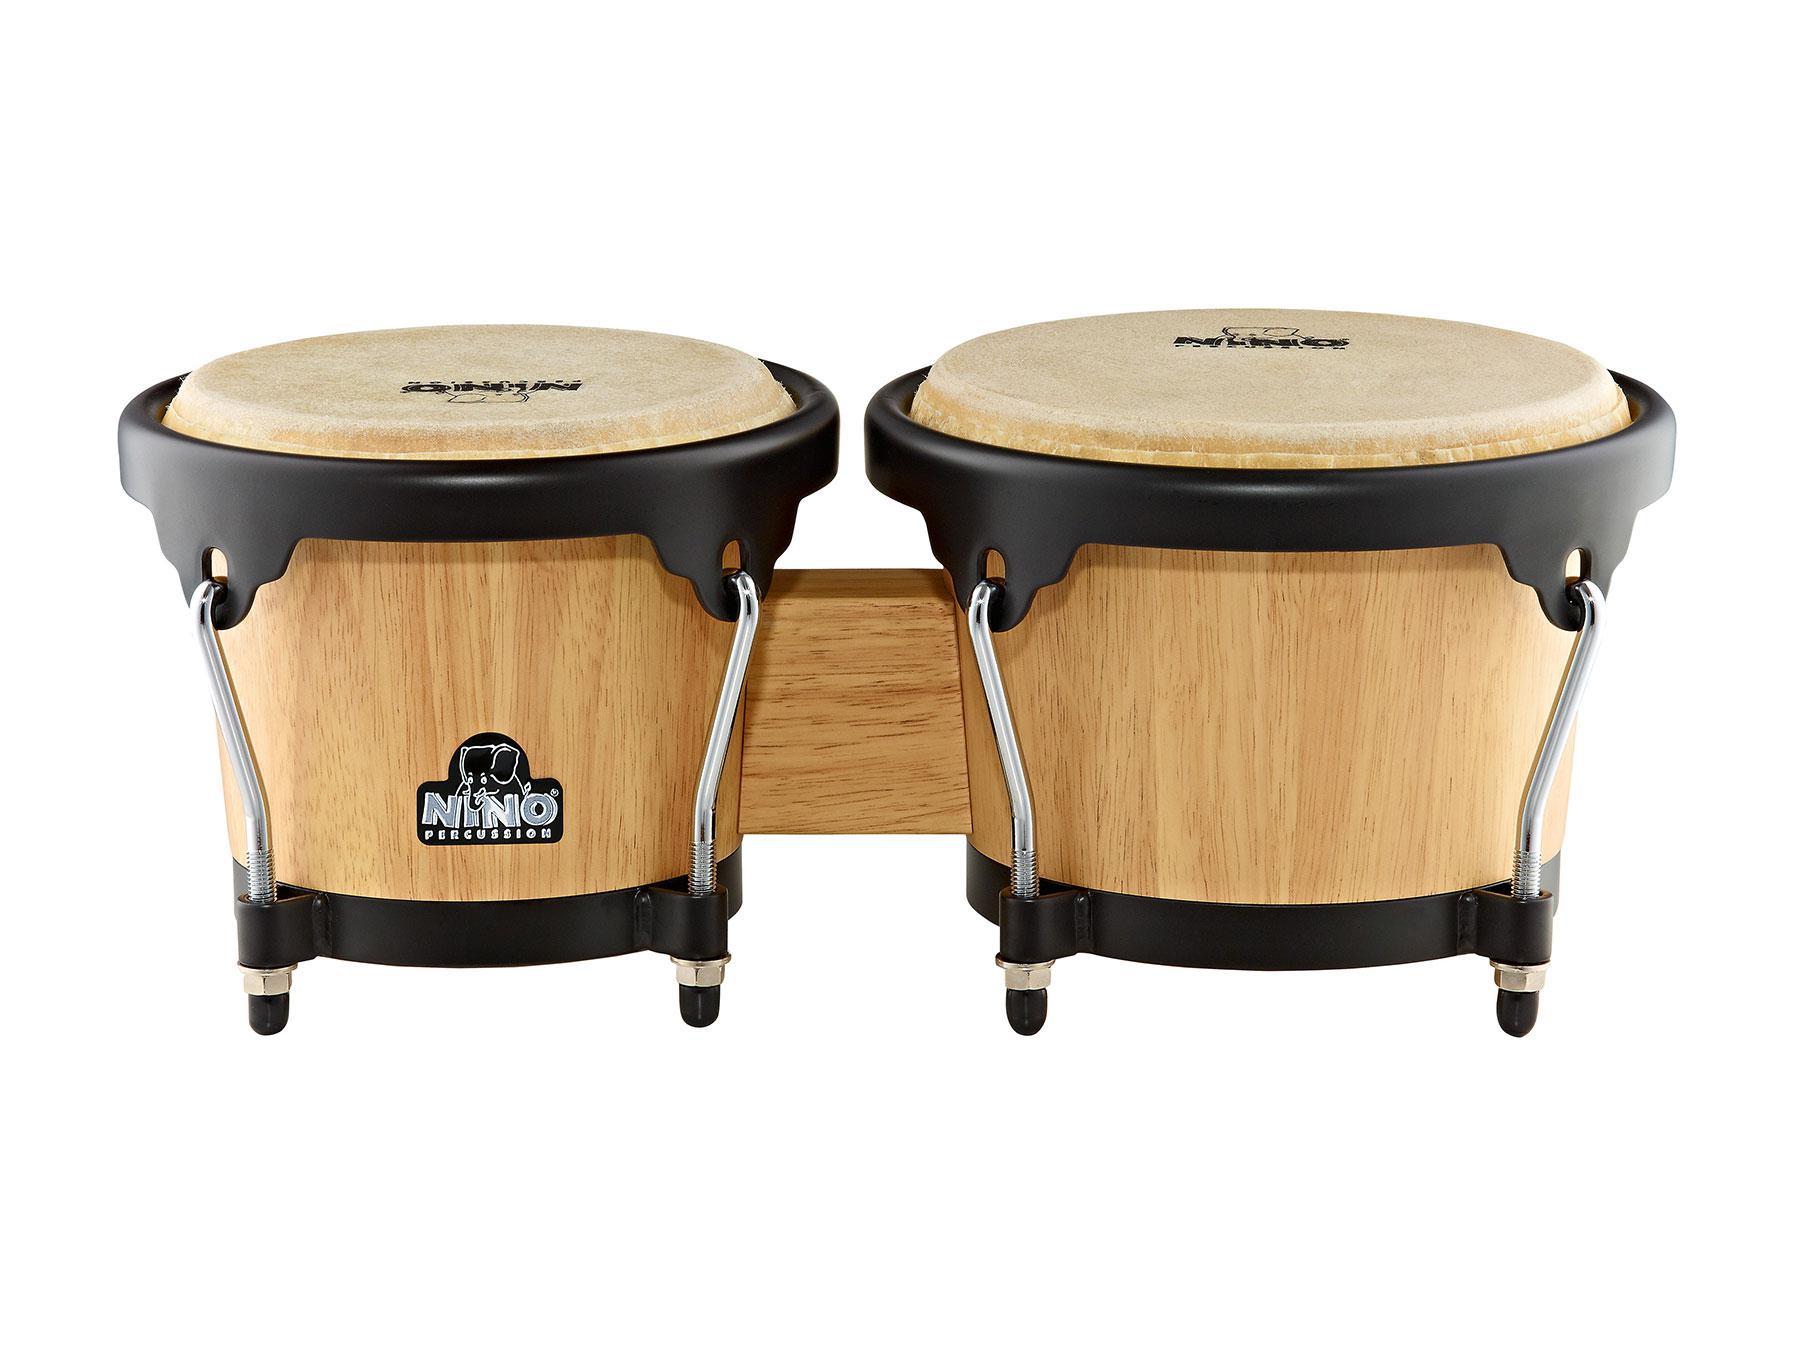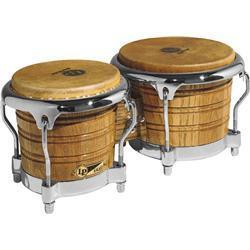The first image is the image on the left, the second image is the image on the right. Considering the images on both sides, is "There are two sets of bongo drums." valid? Answer yes or no. Yes. The first image is the image on the left, the second image is the image on the right. Examine the images to the left and right. Is the description "Each image contains one connected, side-by-side pair of drums with short feet on each drum, and one of the drum pairs is brown with multiple parallel lines encircling it." accurate? Answer yes or no. Yes. 